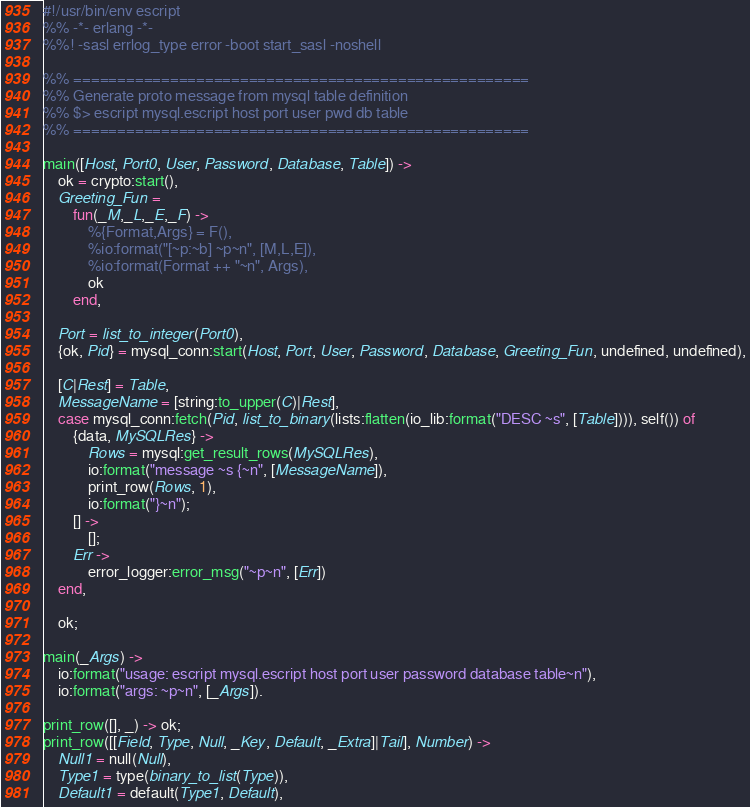<code> <loc_0><loc_0><loc_500><loc_500><_Erlang_>#!/usr/bin/env escript
%% -*- erlang -*-
%%! -sasl errlog_type error -boot start_sasl -noshell

%% ====================================================
%% Generate proto message from mysql table definition
%% $> escript mysql.escript host port user pwd db table
%% ====================================================

main([Host, Port0, User, Password, Database, Table]) ->
	ok = crypto:start(),
	Greeting_Fun =
		fun(_M,_L,_E,_F) -> 
			%{Format,Args} = F(),
			%io:format("[~p:~b] ~p~n", [M,L,E]),
			%io:format(Format ++ "~n", Args),
			ok
		end,
		
	Port = list_to_integer(Port0),
	{ok, Pid} = mysql_conn:start(Host, Port, User, Password, Database, Greeting_Fun, undefined, undefined),

	[C|Rest] = Table,
	MessageName = [string:to_upper(C)|Rest],
	case mysql_conn:fetch(Pid, list_to_binary(lists:flatten(io_lib:format("DESC ~s", [Table]))), self()) of 
        {data, MySQLRes} ->
            Rows = mysql:get_result_rows(MySQLRes),
			io:format("message ~s {~n", [MessageName]),
			print_row(Rows, 1),
			io:format("}~n");
		[] -> 
			[];
		Err -> 
			error_logger:error_msg("~p~n", [Err])
    end,

	ok;
	
main(_Args) ->
	io:format("usage: escript mysql.escript host port user password database table~n"),
	io:format("args: ~p~n", [_Args]).
	
print_row([], _) -> ok;
print_row([[Field, Type, Null, _Key, Default, _Extra]|Tail], Number) ->
	Null1 = null(Null),
	Type1 = type(binary_to_list(Type)),
	Default1 = default(Type1, Default),</code> 